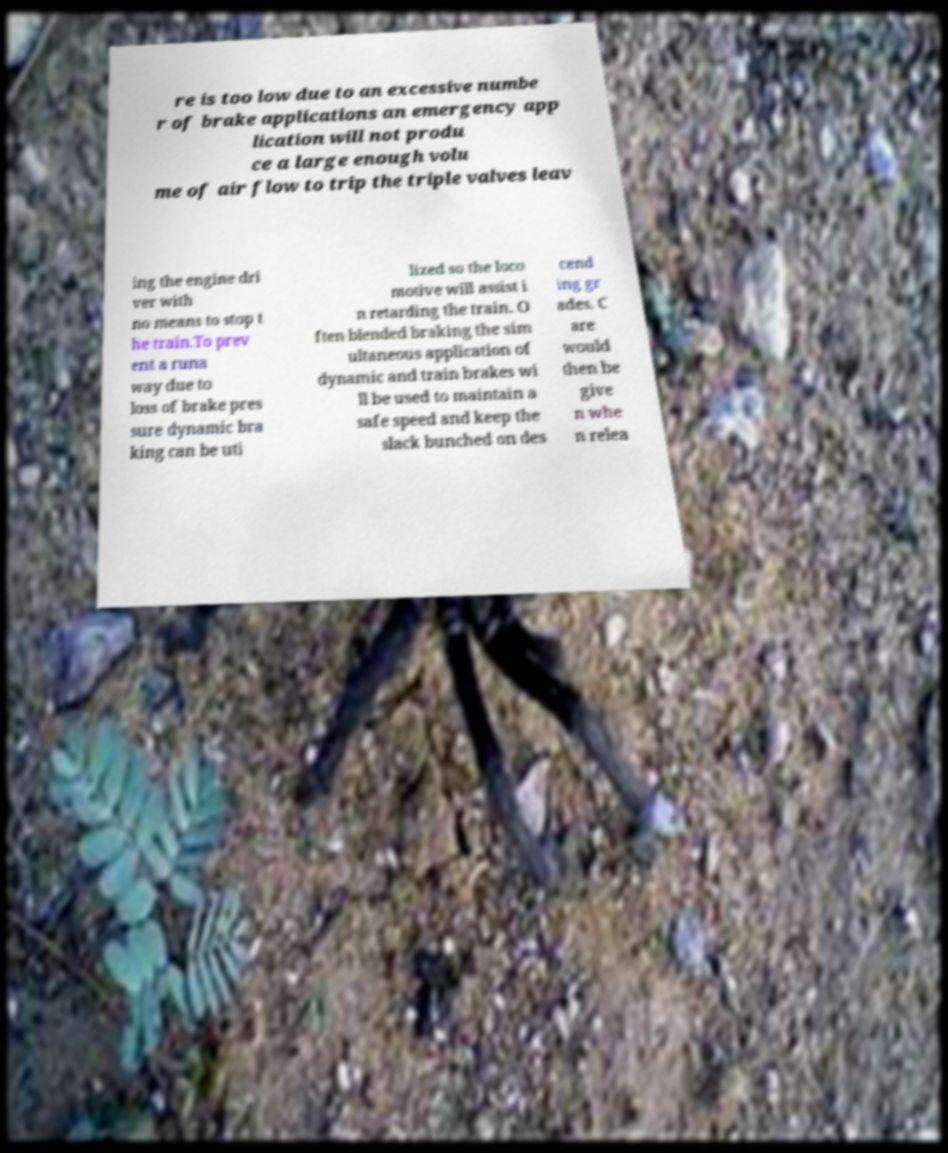Please identify and transcribe the text found in this image. re is too low due to an excessive numbe r of brake applications an emergency app lication will not produ ce a large enough volu me of air flow to trip the triple valves leav ing the engine dri ver with no means to stop t he train.To prev ent a runa way due to loss of brake pres sure dynamic bra king can be uti lized so the loco motive will assist i n retarding the train. O ften blended braking the sim ultaneous application of dynamic and train brakes wi ll be used to maintain a safe speed and keep the slack bunched on des cend ing gr ades. C are would then be give n whe n relea 